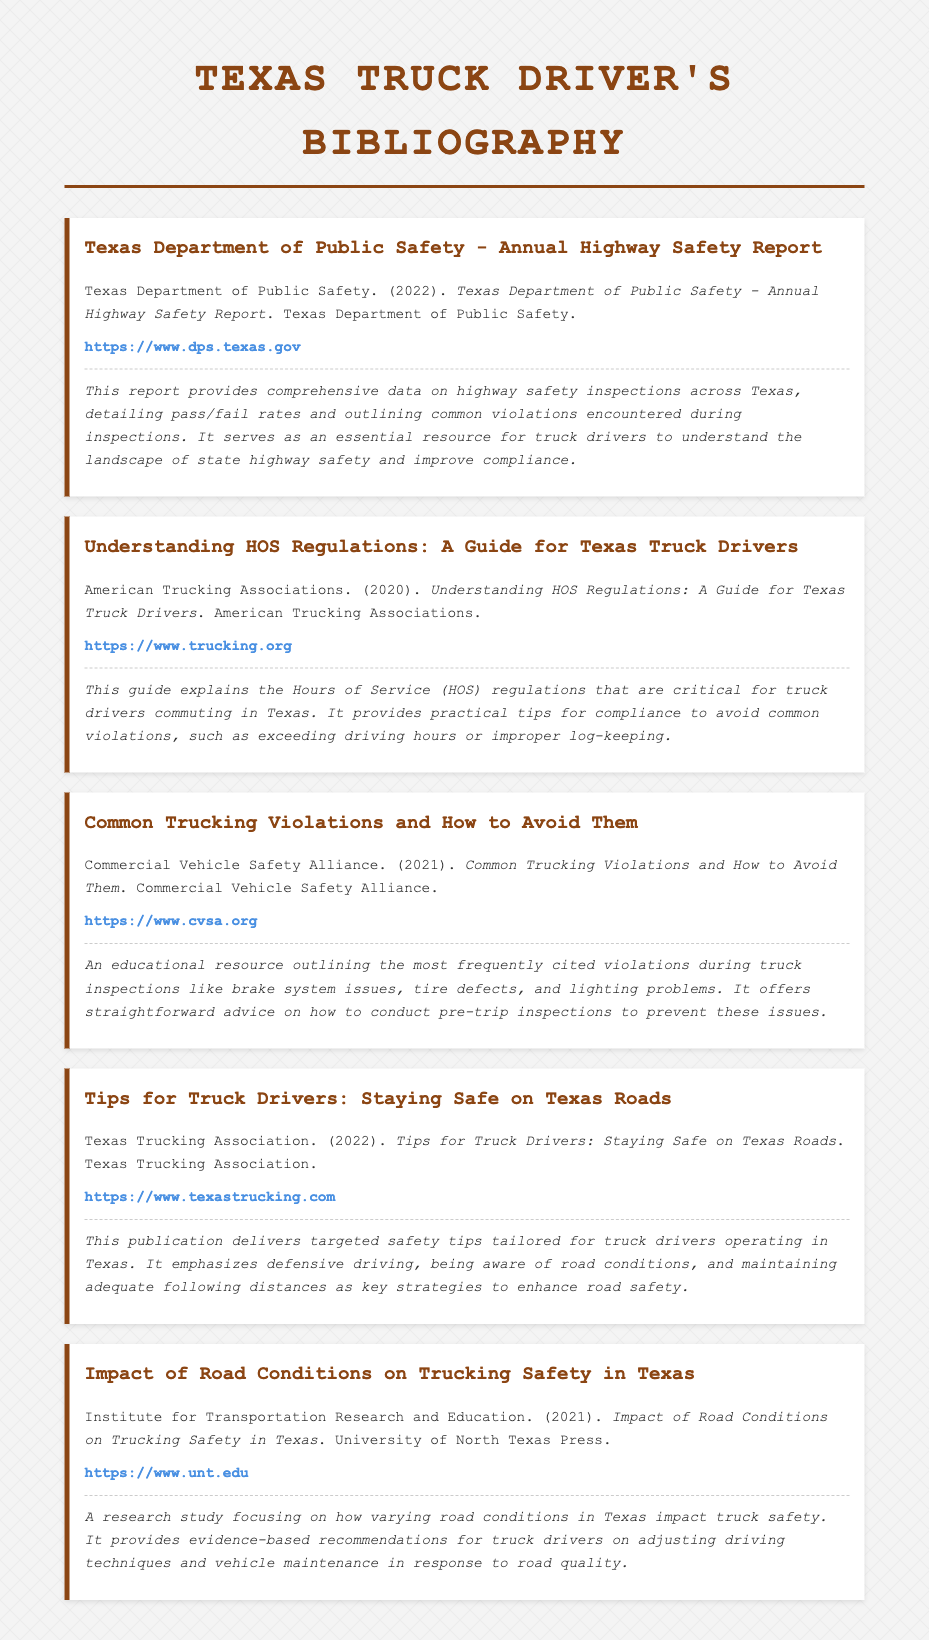what is the title of the first entry? The first entry discusses the Texas Department of Public Safety's annual report on highway safety.
Answer: Texas Department of Public Safety - Annual Highway Safety Report who published the guide on HOS regulations? The guide on Hours of Service regulations is published by the American Trucking Associations.
Answer: American Trucking Associations what year was the "Common Trucking Violations and How to Avoid Them" published? This document was released in the year 2021, as indicated in the citation.
Answer: 2021 which association provides tips for truck drivers in Texas? The publication providing tips for truck drivers is from the Texas Trucking Association.
Answer: Texas Trucking Association how many entries are listed in the document? The document contains a total of five distinct entries, each focused on a different aspect of truck safety.
Answer: Five what is the focus of the last entry in the bibliography? The last entry discusses the impact of varying road conditions on truck safety and offers recommendations based on research findings.
Answer: Impact of Road Conditions on Trucking Safety in Texas which website is mentioned for the Texas Department of Public Safety? The website provided for the Texas Department of Public Safety is available for additional resource access.
Answer: https://www.dps.texas.gov what publication year is associated with the "Tips for Truck Drivers" entry? This publication entry was released in the year 2022, as noted in the document.
Answer: 2022 